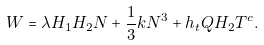Convert formula to latex. <formula><loc_0><loc_0><loc_500><loc_500>W = \lambda { H } _ { 1 } { H } _ { 2 } { N } + { \frac { 1 } { 3 } } k { N } ^ { 3 } + h _ { t } { Q } { H } _ { 2 } { T } ^ { c } .</formula> 